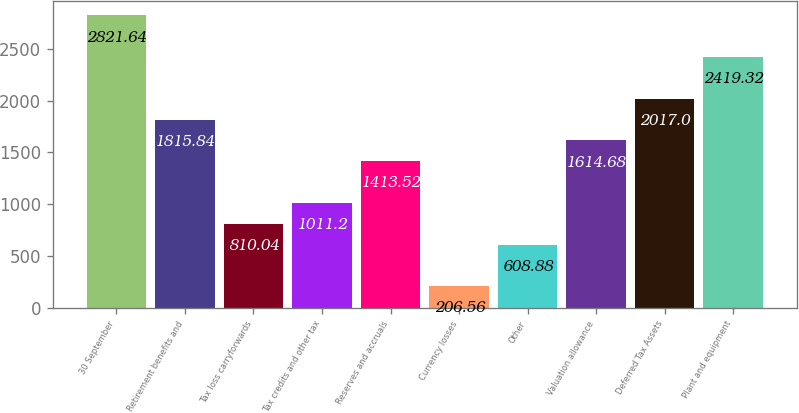Convert chart. <chart><loc_0><loc_0><loc_500><loc_500><bar_chart><fcel>30 September<fcel>Retirement benefits and<fcel>Tax loss carryforwards<fcel>Tax credits and other tax<fcel>Reserves and accruals<fcel>Currency losses<fcel>Other<fcel>Valuation allowance<fcel>Deferred Tax Assets<fcel>Plant and equipment<nl><fcel>2821.64<fcel>1815.84<fcel>810.04<fcel>1011.2<fcel>1413.52<fcel>206.56<fcel>608.88<fcel>1614.68<fcel>2017<fcel>2419.32<nl></chart> 